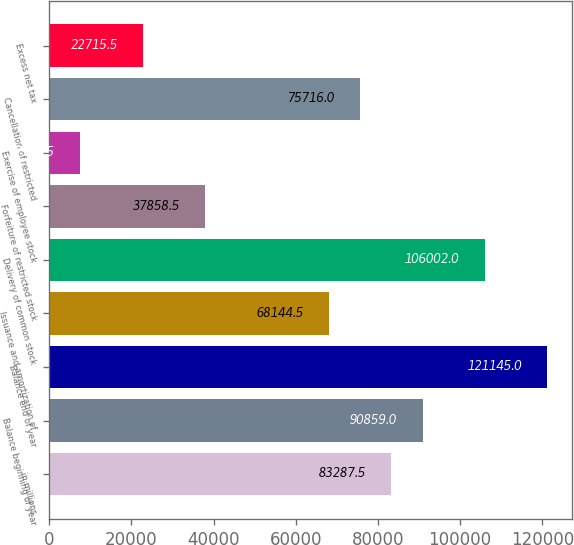<chart> <loc_0><loc_0><loc_500><loc_500><bar_chart><fcel>in millions<fcel>Balance beginning of year<fcel>Balance end of year<fcel>Issuance and amortization of<fcel>Delivery of common stock<fcel>Forfeiture of restricted stock<fcel>Exercise of employee stock<fcel>Cancellation of restricted<fcel>Excess net tax<nl><fcel>83287.5<fcel>90859<fcel>121145<fcel>68144.5<fcel>106002<fcel>37858.5<fcel>7572.5<fcel>75716<fcel>22715.5<nl></chart> 